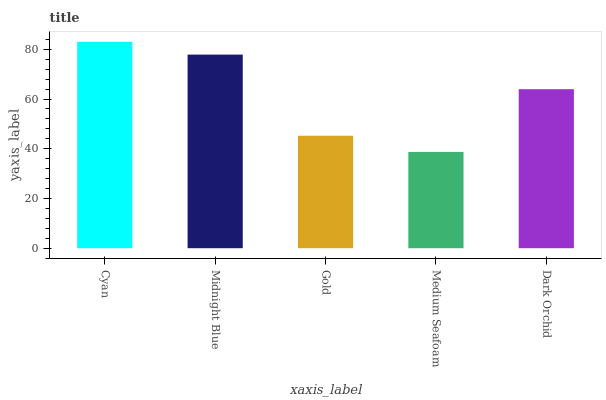Is Medium Seafoam the minimum?
Answer yes or no. Yes. Is Cyan the maximum?
Answer yes or no. Yes. Is Midnight Blue the minimum?
Answer yes or no. No. Is Midnight Blue the maximum?
Answer yes or no. No. Is Cyan greater than Midnight Blue?
Answer yes or no. Yes. Is Midnight Blue less than Cyan?
Answer yes or no. Yes. Is Midnight Blue greater than Cyan?
Answer yes or no. No. Is Cyan less than Midnight Blue?
Answer yes or no. No. Is Dark Orchid the high median?
Answer yes or no. Yes. Is Dark Orchid the low median?
Answer yes or no. Yes. Is Gold the high median?
Answer yes or no. No. Is Cyan the low median?
Answer yes or no. No. 